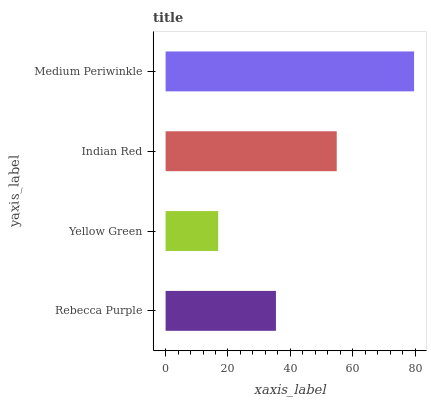Is Yellow Green the minimum?
Answer yes or no. Yes. Is Medium Periwinkle the maximum?
Answer yes or no. Yes. Is Indian Red the minimum?
Answer yes or no. No. Is Indian Red the maximum?
Answer yes or no. No. Is Indian Red greater than Yellow Green?
Answer yes or no. Yes. Is Yellow Green less than Indian Red?
Answer yes or no. Yes. Is Yellow Green greater than Indian Red?
Answer yes or no. No. Is Indian Red less than Yellow Green?
Answer yes or no. No. Is Indian Red the high median?
Answer yes or no. Yes. Is Rebecca Purple the low median?
Answer yes or no. Yes. Is Yellow Green the high median?
Answer yes or no. No. Is Indian Red the low median?
Answer yes or no. No. 